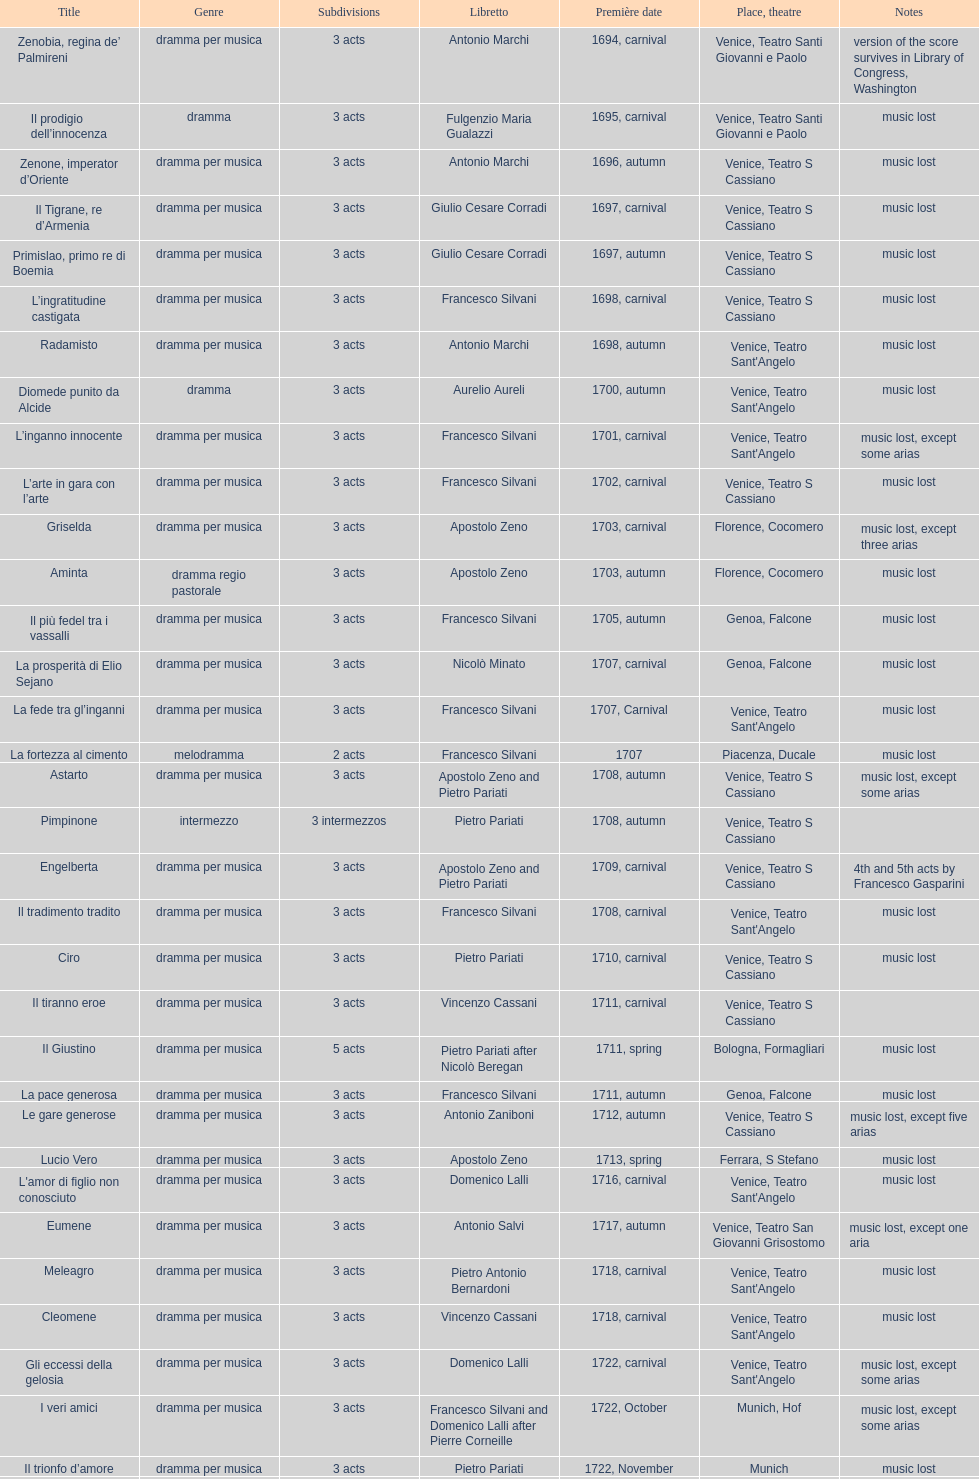How many were launched following zenone, imperator d'oriente? 52. 